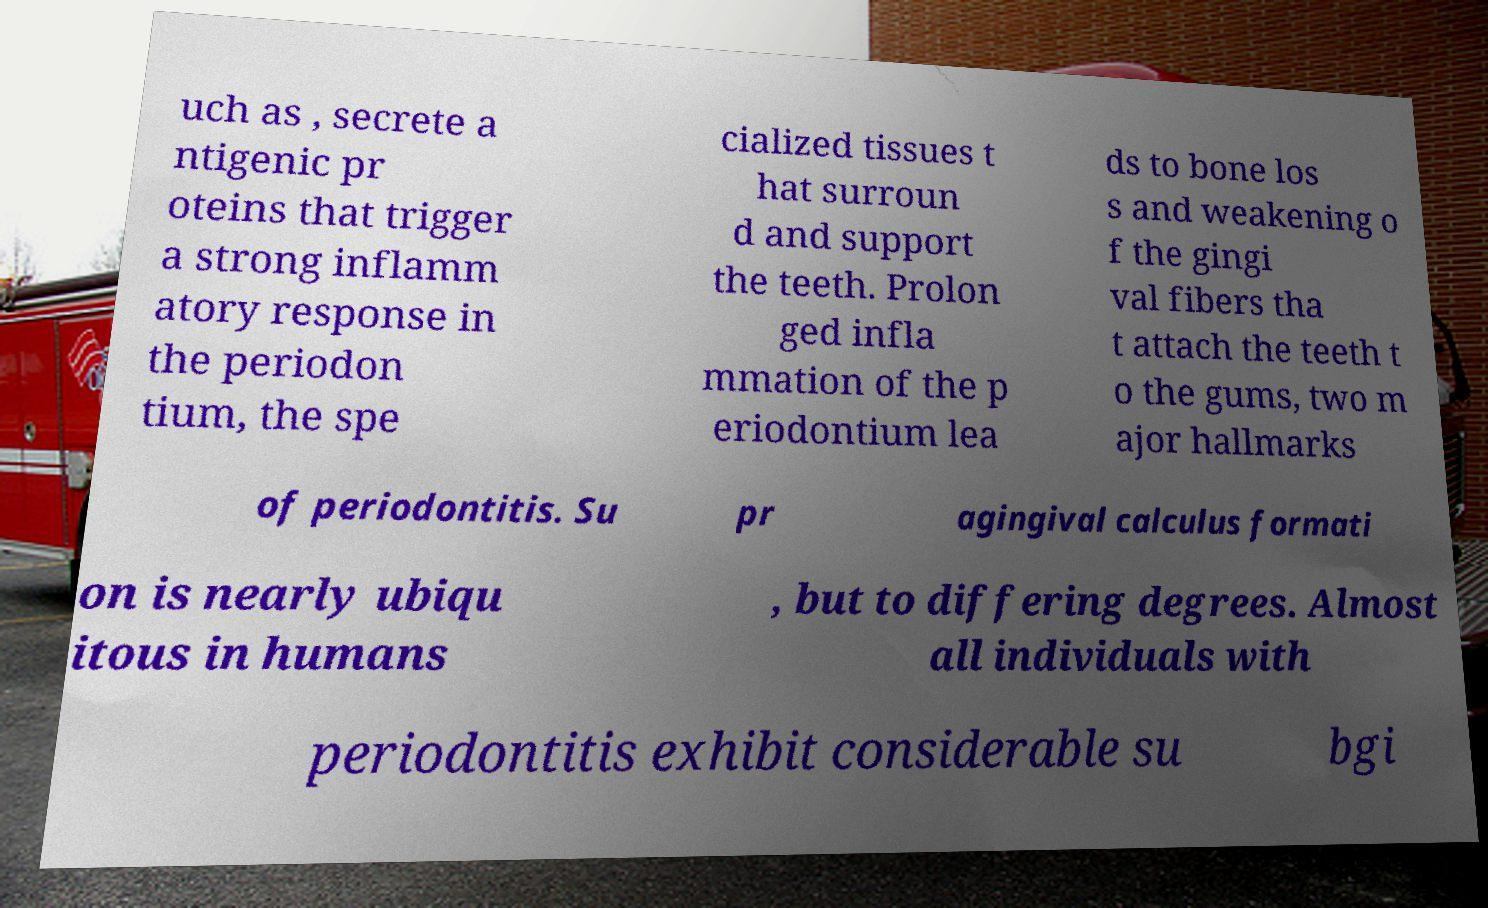Can you accurately transcribe the text from the provided image for me? uch as , secrete a ntigenic pr oteins that trigger a strong inflamm atory response in the periodon tium, the spe cialized tissues t hat surroun d and support the teeth. Prolon ged infla mmation of the p eriodontium lea ds to bone los s and weakening o f the gingi val fibers tha t attach the teeth t o the gums, two m ajor hallmarks of periodontitis. Su pr agingival calculus formati on is nearly ubiqu itous in humans , but to differing degrees. Almost all individuals with periodontitis exhibit considerable su bgi 